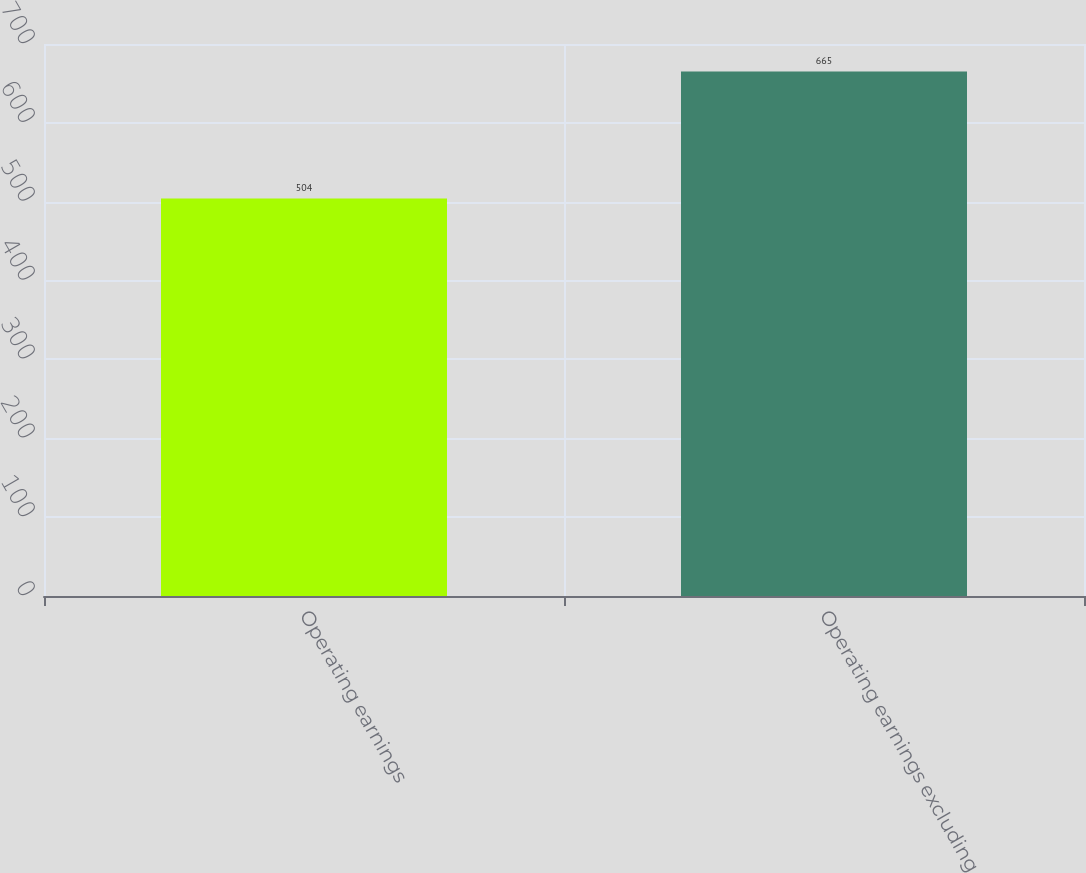Convert chart to OTSL. <chart><loc_0><loc_0><loc_500><loc_500><bar_chart><fcel>Operating earnings<fcel>Operating earnings excluding<nl><fcel>504<fcel>665<nl></chart> 